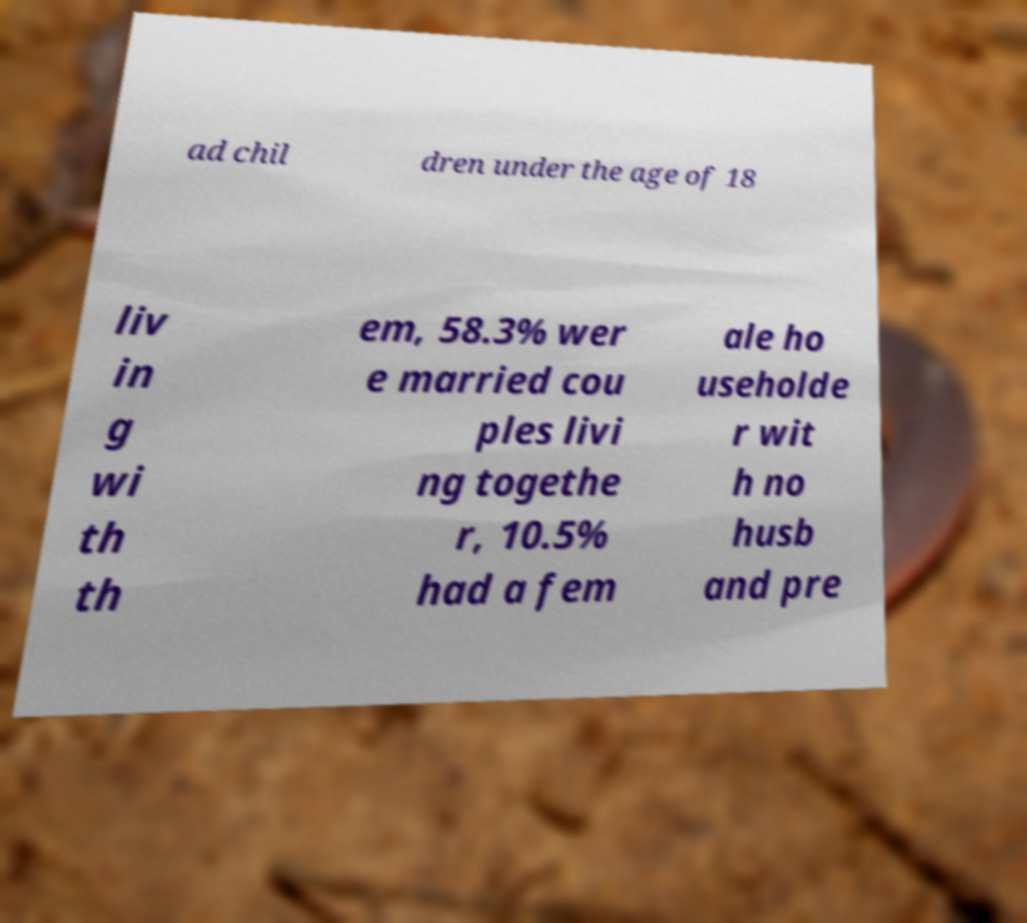Can you read and provide the text displayed in the image?This photo seems to have some interesting text. Can you extract and type it out for me? ad chil dren under the age of 18 liv in g wi th th em, 58.3% wer e married cou ples livi ng togethe r, 10.5% had a fem ale ho useholde r wit h no husb and pre 